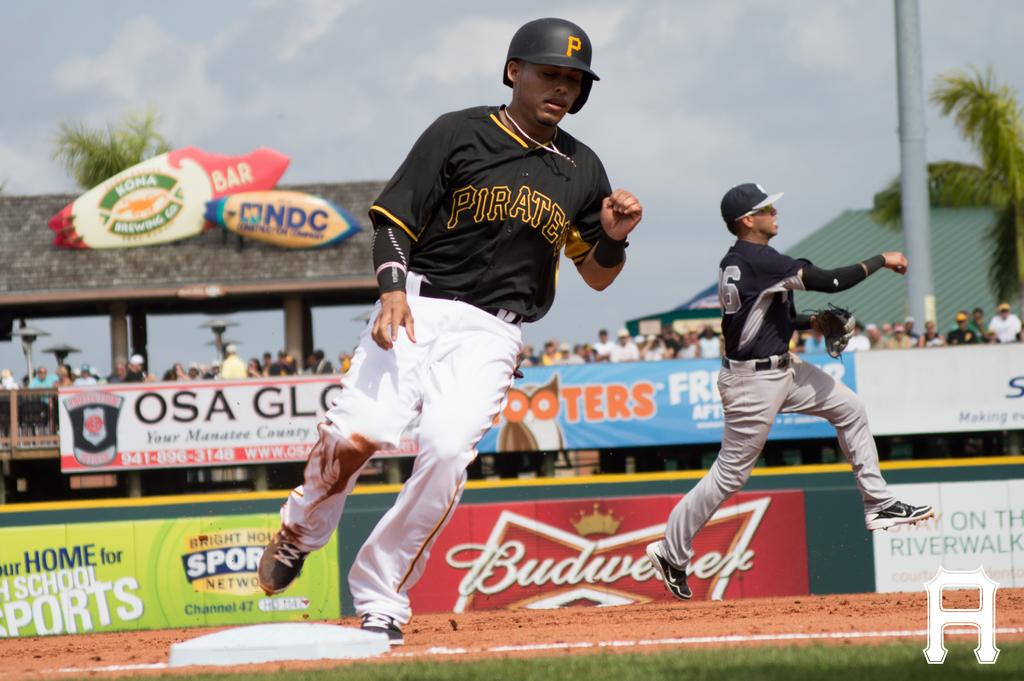<image>
Describe the image concisely. The Pirates are playing baseball in front of a Budweiser sign. 